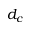<formula> <loc_0><loc_0><loc_500><loc_500>d _ { c }</formula> 